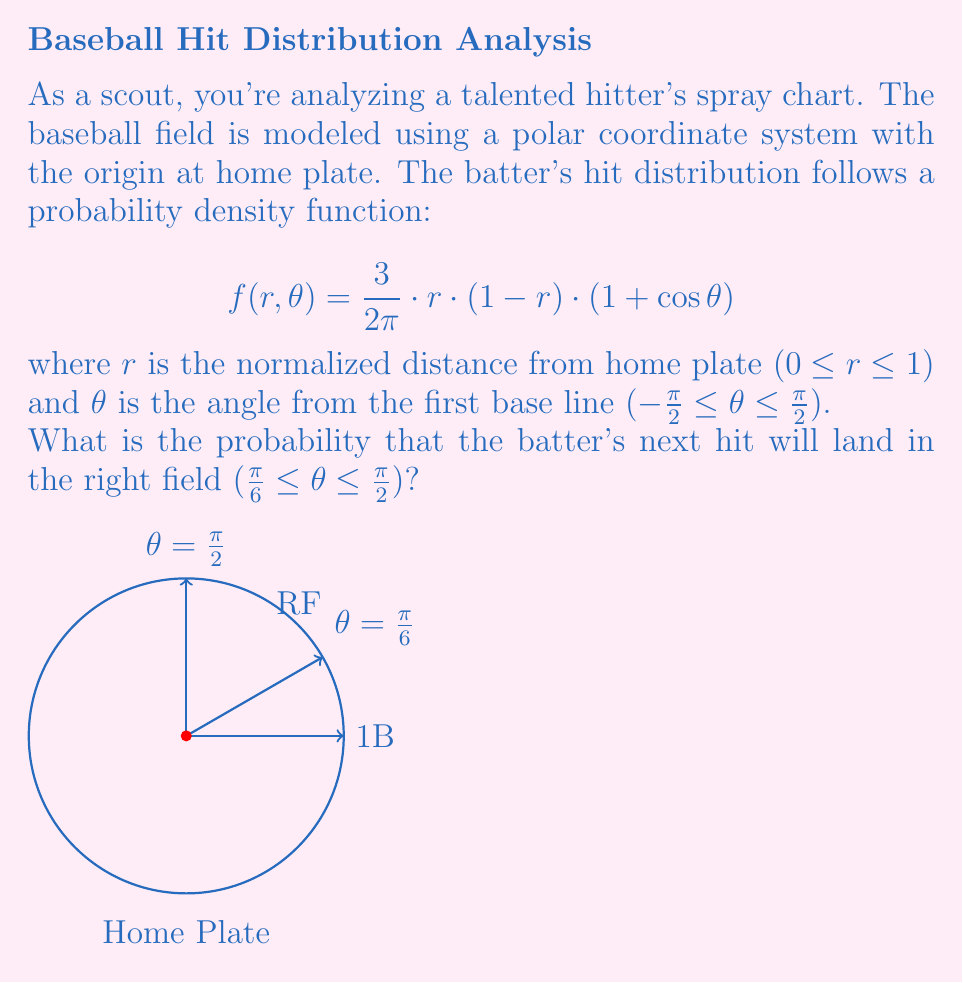Show me your answer to this math problem. To solve this problem, we need to integrate the probability density function over the right field area. Here's the step-by-step solution:

1) The probability is given by the double integral:

   $$P(\text{Right Field}) = \int_{\pi/6}^{\pi/2} \int_0^1 f(r,\theta) \, dr \, d\theta$$

2) Substitute the given function:

   $$P(\text{Right Field}) = \int_{\pi/6}^{\pi/2} \int_0^1 \frac{3}{2\pi} \cdot r \cdot (1-r) \cdot (1+\cos\theta) \, dr \, d\theta$$

3) First, integrate with respect to r:

   $$\int_0^1 r(1-r) \, dr = \int_0^1 (r-r^2) \, dr = [\frac{r^2}{2} - \frac{r^3}{3}]_0^1 = \frac{1}{2} - \frac{1}{3} = \frac{1}{6}$$

4) Now our integral becomes:

   $$P(\text{Right Field}) = \frac{3}{2\pi} \cdot \frac{1}{6} \int_{\pi/6}^{\pi/2} (1+\cos\theta) \, d\theta$$

5) Integrate with respect to θ:

   $$\frac{1}{4\pi} [\theta + \sin\theta]_{\pi/6}^{\pi/2}$$

6) Evaluate the limits:

   $$\frac{1}{4\pi} [(\frac{\pi}{2} + 0) - (\frac{\pi}{6} + \frac{\sqrt{3}}{2})]$$

7) Simplify:

   $$\frac{1}{4\pi} [\frac{\pi}{3} - \frac{\sqrt{3}}{2}]$$

8) This is our final answer, which can be left as is or approximated to a decimal.
Answer: $\frac{1}{4\pi} [\frac{\pi}{3} - \frac{\sqrt{3}}{2}]$ or approximately 0.1988 